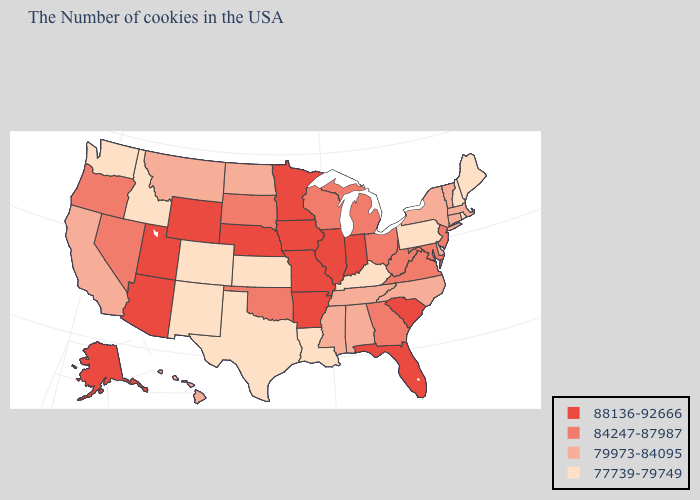What is the lowest value in states that border Illinois?
Be succinct. 77739-79749. Name the states that have a value in the range 77739-79749?
Concise answer only. Maine, Rhode Island, New Hampshire, Pennsylvania, Kentucky, Louisiana, Kansas, Texas, Colorado, New Mexico, Idaho, Washington. What is the value of Wyoming?
Write a very short answer. 88136-92666. Among the states that border Idaho , which have the highest value?
Concise answer only. Wyoming, Utah. What is the highest value in the South ?
Concise answer only. 88136-92666. What is the lowest value in the USA?
Write a very short answer. 77739-79749. What is the highest value in the Northeast ?
Write a very short answer. 84247-87987. Which states have the highest value in the USA?
Give a very brief answer. South Carolina, Florida, Indiana, Illinois, Missouri, Arkansas, Minnesota, Iowa, Nebraska, Wyoming, Utah, Arizona, Alaska. What is the value of Louisiana?
Concise answer only. 77739-79749. Does Montana have a higher value than Pennsylvania?
Answer briefly. Yes. Does Ohio have a higher value than Missouri?
Short answer required. No. What is the lowest value in the USA?
Be succinct. 77739-79749. What is the value of Rhode Island?
Be succinct. 77739-79749. Does New Jersey have the lowest value in the Northeast?
Concise answer only. No. Does Georgia have a higher value than Colorado?
Write a very short answer. Yes. 